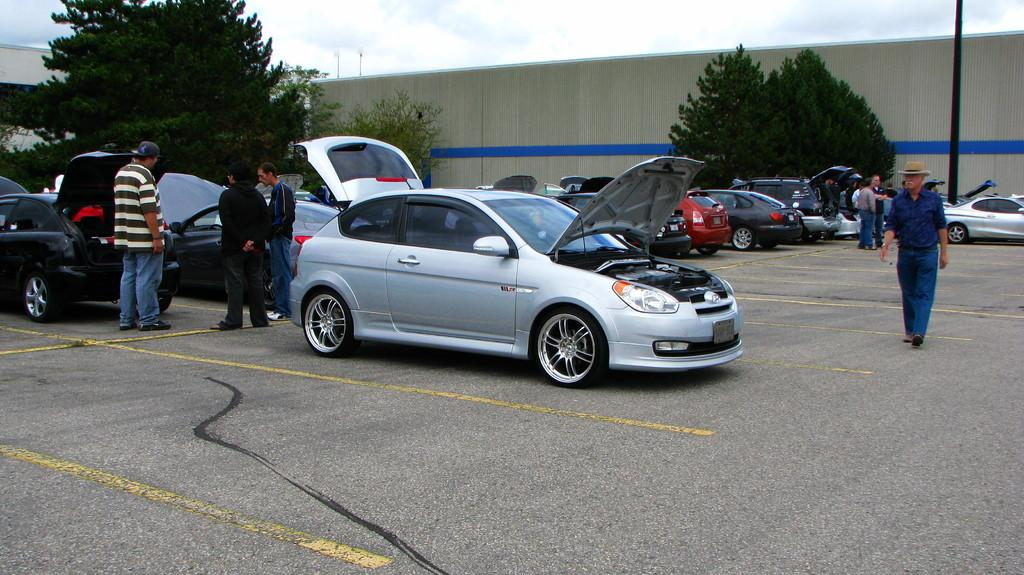What is the main subject of the image? The main subject of the image is a group of cars. What else can be seen in the image besides the cars? There are people standing on the ground, a wall, trees, poles, and the sky visible in the background of the image. What type of glue is being used to hold the middle of the car together in the image? There is no glue or indication of any damage to the cars in the image; they appear to be in good condition. 